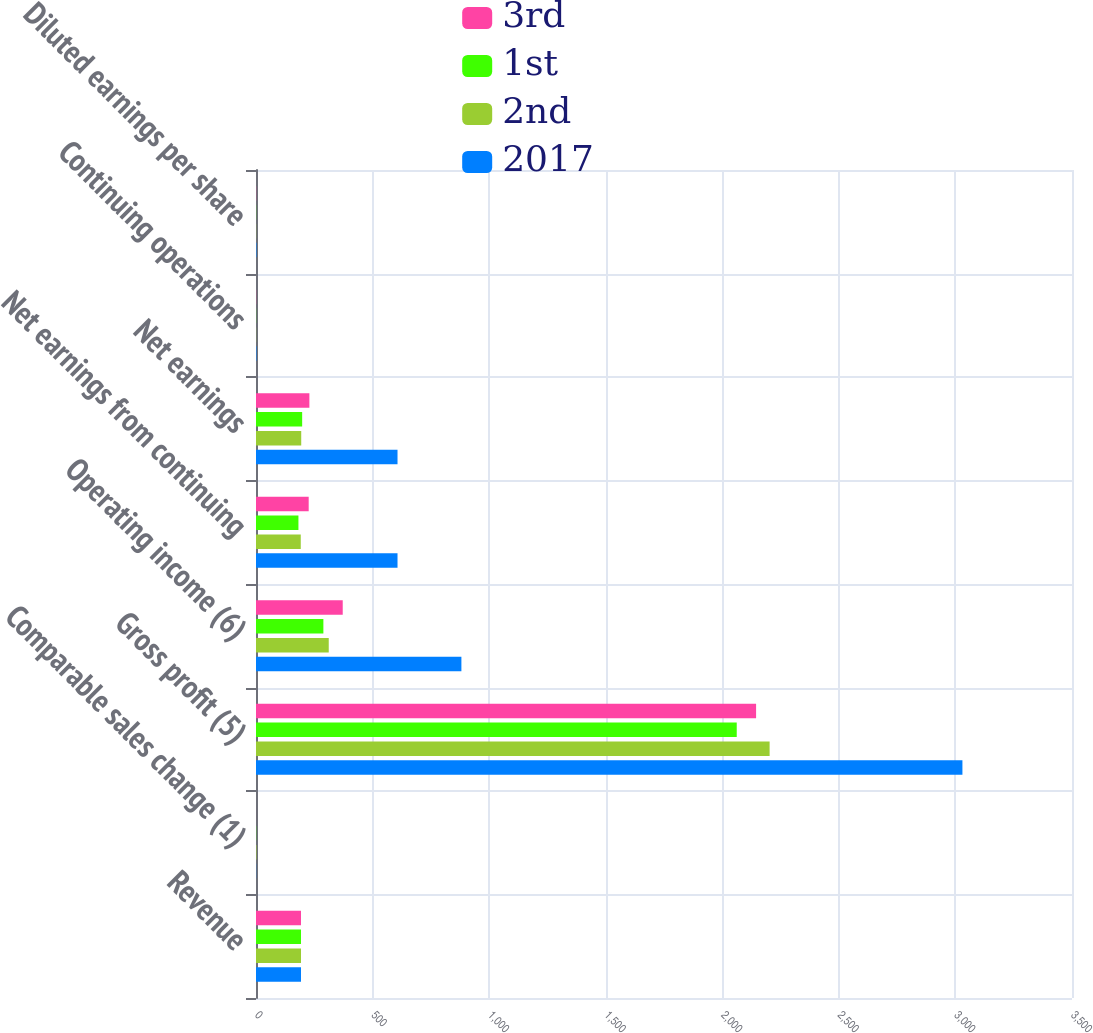Convert chart. <chart><loc_0><loc_0><loc_500><loc_500><stacked_bar_chart><ecel><fcel>Revenue<fcel>Comparable sales change (1)<fcel>Gross profit (5)<fcel>Operating income (6)<fcel>Net earnings from continuing<fcel>Net earnings<fcel>Continuing operations<fcel>Diluted earnings per share<nl><fcel>3rd<fcel>193<fcel>0.1<fcel>2145<fcel>372<fcel>226<fcel>229<fcel>0.69<fcel>0.7<nl><fcel>1st<fcel>193<fcel>0.8<fcel>2062<fcel>289<fcel>182<fcel>198<fcel>0.56<fcel>0.61<nl><fcel>2nd<fcel>193<fcel>1.8<fcel>2203<fcel>312<fcel>192<fcel>194<fcel>0.6<fcel>0.61<nl><fcel>2017<fcel>193<fcel>0.7<fcel>3030<fcel>881<fcel>607<fcel>607<fcel>1.91<fcel>1.91<nl></chart> 